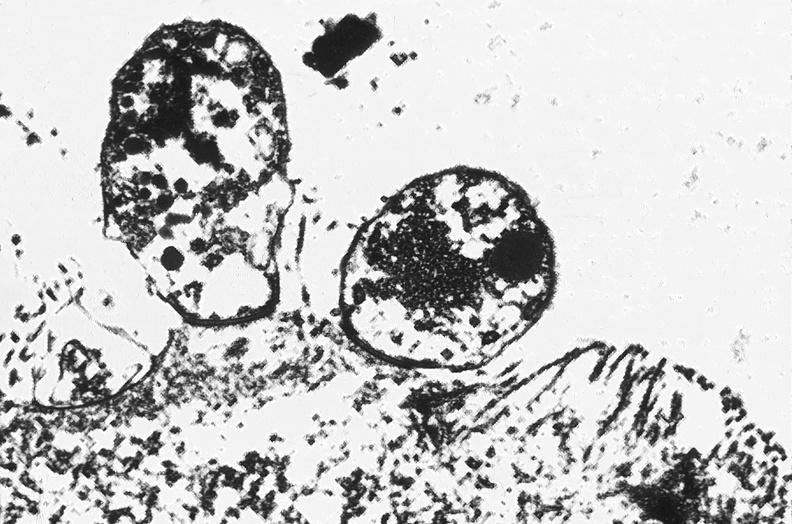does this image show colon, cryptosporidia?
Answer the question using a single word or phrase. Yes 